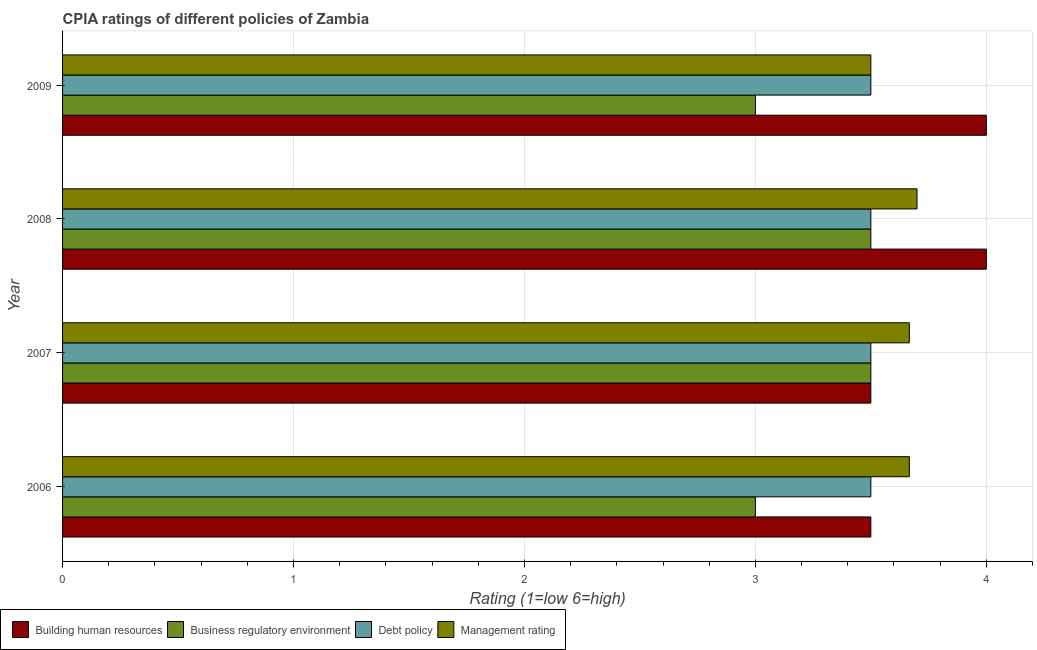How many groups of bars are there?
Your response must be concise. 4. Are the number of bars per tick equal to the number of legend labels?
Give a very brief answer. Yes. In how many cases, is the number of bars for a given year not equal to the number of legend labels?
Offer a very short reply. 0. Across all years, what is the maximum cpia rating of debt policy?
Provide a succinct answer. 3.5. Across all years, what is the minimum cpia rating of debt policy?
Offer a very short reply. 3.5. What is the total cpia rating of management in the graph?
Provide a succinct answer. 14.53. What is the difference between the cpia rating of management in 2006 and that in 2008?
Your answer should be compact. -0.03. In the year 2008, what is the difference between the cpia rating of debt policy and cpia rating of business regulatory environment?
Make the answer very short. 0. What is the ratio of the cpia rating of business regulatory environment in 2006 to that in 2008?
Your answer should be compact. 0.86. Is the cpia rating of debt policy in 2006 less than that in 2007?
Provide a short and direct response. No. What is the difference between the highest and the second highest cpia rating of management?
Provide a succinct answer. 0.03. Is the sum of the cpia rating of building human resources in 2006 and 2009 greater than the maximum cpia rating of management across all years?
Provide a succinct answer. Yes. What does the 1st bar from the top in 2007 represents?
Your answer should be compact. Management rating. What does the 2nd bar from the bottom in 2006 represents?
Your answer should be very brief. Business regulatory environment. Is it the case that in every year, the sum of the cpia rating of building human resources and cpia rating of business regulatory environment is greater than the cpia rating of debt policy?
Provide a succinct answer. Yes. How many bars are there?
Keep it short and to the point. 16. Are all the bars in the graph horizontal?
Provide a succinct answer. Yes. How many years are there in the graph?
Give a very brief answer. 4. What is the difference between two consecutive major ticks on the X-axis?
Make the answer very short. 1. Are the values on the major ticks of X-axis written in scientific E-notation?
Give a very brief answer. No. Does the graph contain any zero values?
Provide a succinct answer. No. Does the graph contain grids?
Your response must be concise. Yes. What is the title of the graph?
Make the answer very short. CPIA ratings of different policies of Zambia. Does "Permission" appear as one of the legend labels in the graph?
Your answer should be compact. No. What is the label or title of the X-axis?
Your response must be concise. Rating (1=low 6=high). What is the label or title of the Y-axis?
Offer a terse response. Year. What is the Rating (1=low 6=high) in Business regulatory environment in 2006?
Your answer should be compact. 3. What is the Rating (1=low 6=high) in Debt policy in 2006?
Keep it short and to the point. 3.5. What is the Rating (1=low 6=high) in Management rating in 2006?
Keep it short and to the point. 3.67. What is the Rating (1=low 6=high) of Building human resources in 2007?
Your answer should be very brief. 3.5. What is the Rating (1=low 6=high) in Business regulatory environment in 2007?
Provide a short and direct response. 3.5. What is the Rating (1=low 6=high) in Debt policy in 2007?
Your answer should be compact. 3.5. What is the Rating (1=low 6=high) in Management rating in 2007?
Keep it short and to the point. 3.67. What is the Rating (1=low 6=high) in Building human resources in 2008?
Your answer should be very brief. 4. What is the Rating (1=low 6=high) of Debt policy in 2008?
Your answer should be compact. 3.5. What is the Rating (1=low 6=high) in Management rating in 2008?
Your answer should be compact. 3.7. What is the Rating (1=low 6=high) in Building human resources in 2009?
Offer a terse response. 4. What is the Rating (1=low 6=high) of Debt policy in 2009?
Your answer should be compact. 3.5. What is the Rating (1=low 6=high) of Management rating in 2009?
Your response must be concise. 3.5. Across all years, what is the maximum Rating (1=low 6=high) in Business regulatory environment?
Make the answer very short. 3.5. Across all years, what is the maximum Rating (1=low 6=high) of Debt policy?
Keep it short and to the point. 3.5. Across all years, what is the minimum Rating (1=low 6=high) of Debt policy?
Give a very brief answer. 3.5. Across all years, what is the minimum Rating (1=low 6=high) of Management rating?
Make the answer very short. 3.5. What is the total Rating (1=low 6=high) of Building human resources in the graph?
Provide a succinct answer. 15. What is the total Rating (1=low 6=high) of Business regulatory environment in the graph?
Offer a very short reply. 13. What is the total Rating (1=low 6=high) of Debt policy in the graph?
Ensure brevity in your answer.  14. What is the total Rating (1=low 6=high) in Management rating in the graph?
Keep it short and to the point. 14.53. What is the difference between the Rating (1=low 6=high) in Building human resources in 2006 and that in 2007?
Make the answer very short. 0. What is the difference between the Rating (1=low 6=high) of Debt policy in 2006 and that in 2007?
Make the answer very short. 0. What is the difference between the Rating (1=low 6=high) of Building human resources in 2006 and that in 2008?
Offer a terse response. -0.5. What is the difference between the Rating (1=low 6=high) of Management rating in 2006 and that in 2008?
Your answer should be very brief. -0.03. What is the difference between the Rating (1=low 6=high) in Business regulatory environment in 2006 and that in 2009?
Offer a very short reply. 0. What is the difference between the Rating (1=low 6=high) of Debt policy in 2006 and that in 2009?
Provide a succinct answer. 0. What is the difference between the Rating (1=low 6=high) in Business regulatory environment in 2007 and that in 2008?
Offer a very short reply. 0. What is the difference between the Rating (1=low 6=high) of Debt policy in 2007 and that in 2008?
Offer a very short reply. 0. What is the difference between the Rating (1=low 6=high) in Management rating in 2007 and that in 2008?
Offer a terse response. -0.03. What is the difference between the Rating (1=low 6=high) in Business regulatory environment in 2007 and that in 2009?
Your answer should be compact. 0.5. What is the difference between the Rating (1=low 6=high) in Debt policy in 2007 and that in 2009?
Give a very brief answer. 0. What is the difference between the Rating (1=low 6=high) of Building human resources in 2008 and that in 2009?
Offer a terse response. 0. What is the difference between the Rating (1=low 6=high) in Building human resources in 2006 and the Rating (1=low 6=high) in Debt policy in 2007?
Your response must be concise. 0. What is the difference between the Rating (1=low 6=high) of Business regulatory environment in 2006 and the Rating (1=low 6=high) of Management rating in 2007?
Your answer should be compact. -0.67. What is the difference between the Rating (1=low 6=high) of Building human resources in 2006 and the Rating (1=low 6=high) of Business regulatory environment in 2008?
Your response must be concise. 0. What is the difference between the Rating (1=low 6=high) in Building human resources in 2006 and the Rating (1=low 6=high) in Debt policy in 2008?
Offer a terse response. 0. What is the difference between the Rating (1=low 6=high) in Building human resources in 2006 and the Rating (1=low 6=high) in Management rating in 2008?
Ensure brevity in your answer.  -0.2. What is the difference between the Rating (1=low 6=high) in Business regulatory environment in 2006 and the Rating (1=low 6=high) in Debt policy in 2008?
Ensure brevity in your answer.  -0.5. What is the difference between the Rating (1=low 6=high) in Business regulatory environment in 2006 and the Rating (1=low 6=high) in Management rating in 2008?
Offer a terse response. -0.7. What is the difference between the Rating (1=low 6=high) in Debt policy in 2006 and the Rating (1=low 6=high) in Management rating in 2008?
Make the answer very short. -0.2. What is the difference between the Rating (1=low 6=high) in Building human resources in 2006 and the Rating (1=low 6=high) in Debt policy in 2009?
Your answer should be very brief. 0. What is the difference between the Rating (1=low 6=high) of Building human resources in 2006 and the Rating (1=low 6=high) of Management rating in 2009?
Provide a short and direct response. 0. What is the difference between the Rating (1=low 6=high) in Debt policy in 2006 and the Rating (1=low 6=high) in Management rating in 2009?
Offer a terse response. 0. What is the difference between the Rating (1=low 6=high) in Building human resources in 2007 and the Rating (1=low 6=high) in Business regulatory environment in 2008?
Your answer should be compact. 0. What is the difference between the Rating (1=low 6=high) in Building human resources in 2007 and the Rating (1=low 6=high) in Debt policy in 2008?
Ensure brevity in your answer.  0. What is the difference between the Rating (1=low 6=high) of Business regulatory environment in 2007 and the Rating (1=low 6=high) of Management rating in 2008?
Offer a terse response. -0.2. What is the difference between the Rating (1=low 6=high) of Building human resources in 2007 and the Rating (1=low 6=high) of Business regulatory environment in 2009?
Keep it short and to the point. 0.5. What is the difference between the Rating (1=low 6=high) of Building human resources in 2007 and the Rating (1=low 6=high) of Management rating in 2009?
Provide a succinct answer. 0. What is the difference between the Rating (1=low 6=high) of Business regulatory environment in 2007 and the Rating (1=low 6=high) of Debt policy in 2009?
Ensure brevity in your answer.  0. What is the difference between the Rating (1=low 6=high) of Debt policy in 2007 and the Rating (1=low 6=high) of Management rating in 2009?
Keep it short and to the point. 0. What is the difference between the Rating (1=low 6=high) in Building human resources in 2008 and the Rating (1=low 6=high) in Debt policy in 2009?
Your response must be concise. 0.5. What is the difference between the Rating (1=low 6=high) in Building human resources in 2008 and the Rating (1=low 6=high) in Management rating in 2009?
Keep it short and to the point. 0.5. What is the difference between the Rating (1=low 6=high) in Business regulatory environment in 2008 and the Rating (1=low 6=high) in Debt policy in 2009?
Offer a terse response. 0. What is the average Rating (1=low 6=high) of Building human resources per year?
Offer a very short reply. 3.75. What is the average Rating (1=low 6=high) in Business regulatory environment per year?
Offer a very short reply. 3.25. What is the average Rating (1=low 6=high) of Debt policy per year?
Make the answer very short. 3.5. What is the average Rating (1=low 6=high) in Management rating per year?
Offer a terse response. 3.63. In the year 2006, what is the difference between the Rating (1=low 6=high) in Building human resources and Rating (1=low 6=high) in Business regulatory environment?
Ensure brevity in your answer.  0.5. In the year 2006, what is the difference between the Rating (1=low 6=high) of Building human resources and Rating (1=low 6=high) of Debt policy?
Ensure brevity in your answer.  0. In the year 2006, what is the difference between the Rating (1=low 6=high) in Building human resources and Rating (1=low 6=high) in Management rating?
Your answer should be very brief. -0.17. In the year 2006, what is the difference between the Rating (1=low 6=high) of Business regulatory environment and Rating (1=low 6=high) of Debt policy?
Your answer should be very brief. -0.5. In the year 2006, what is the difference between the Rating (1=low 6=high) in Business regulatory environment and Rating (1=low 6=high) in Management rating?
Make the answer very short. -0.67. In the year 2006, what is the difference between the Rating (1=low 6=high) in Debt policy and Rating (1=low 6=high) in Management rating?
Keep it short and to the point. -0.17. In the year 2007, what is the difference between the Rating (1=low 6=high) in Building human resources and Rating (1=low 6=high) in Debt policy?
Offer a terse response. 0. In the year 2007, what is the difference between the Rating (1=low 6=high) in Business regulatory environment and Rating (1=low 6=high) in Debt policy?
Your answer should be compact. 0. In the year 2007, what is the difference between the Rating (1=low 6=high) in Debt policy and Rating (1=low 6=high) in Management rating?
Keep it short and to the point. -0.17. In the year 2008, what is the difference between the Rating (1=low 6=high) in Building human resources and Rating (1=low 6=high) in Debt policy?
Your answer should be compact. 0.5. In the year 2008, what is the difference between the Rating (1=low 6=high) in Building human resources and Rating (1=low 6=high) in Management rating?
Make the answer very short. 0.3. In the year 2008, what is the difference between the Rating (1=low 6=high) in Business regulatory environment and Rating (1=low 6=high) in Debt policy?
Make the answer very short. 0. In the year 2008, what is the difference between the Rating (1=low 6=high) of Business regulatory environment and Rating (1=low 6=high) of Management rating?
Your response must be concise. -0.2. In the year 2008, what is the difference between the Rating (1=low 6=high) of Debt policy and Rating (1=low 6=high) of Management rating?
Keep it short and to the point. -0.2. In the year 2009, what is the difference between the Rating (1=low 6=high) in Building human resources and Rating (1=low 6=high) in Business regulatory environment?
Ensure brevity in your answer.  1. In the year 2009, what is the difference between the Rating (1=low 6=high) of Building human resources and Rating (1=low 6=high) of Debt policy?
Provide a succinct answer. 0.5. In the year 2009, what is the difference between the Rating (1=low 6=high) in Business regulatory environment and Rating (1=low 6=high) in Debt policy?
Offer a terse response. -0.5. What is the ratio of the Rating (1=low 6=high) in Business regulatory environment in 2006 to that in 2007?
Your response must be concise. 0.86. What is the ratio of the Rating (1=low 6=high) in Management rating in 2006 to that in 2007?
Provide a succinct answer. 1. What is the ratio of the Rating (1=low 6=high) of Building human resources in 2006 to that in 2008?
Your answer should be very brief. 0.88. What is the ratio of the Rating (1=low 6=high) of Debt policy in 2006 to that in 2008?
Provide a succinct answer. 1. What is the ratio of the Rating (1=low 6=high) in Building human resources in 2006 to that in 2009?
Offer a terse response. 0.88. What is the ratio of the Rating (1=low 6=high) in Management rating in 2006 to that in 2009?
Keep it short and to the point. 1.05. What is the ratio of the Rating (1=low 6=high) of Building human resources in 2007 to that in 2008?
Your answer should be compact. 0.88. What is the ratio of the Rating (1=low 6=high) of Debt policy in 2007 to that in 2008?
Offer a terse response. 1. What is the ratio of the Rating (1=low 6=high) of Management rating in 2007 to that in 2008?
Provide a succinct answer. 0.99. What is the ratio of the Rating (1=low 6=high) in Business regulatory environment in 2007 to that in 2009?
Your answer should be very brief. 1.17. What is the ratio of the Rating (1=low 6=high) in Debt policy in 2007 to that in 2009?
Provide a short and direct response. 1. What is the ratio of the Rating (1=low 6=high) in Management rating in 2007 to that in 2009?
Your answer should be very brief. 1.05. What is the ratio of the Rating (1=low 6=high) in Debt policy in 2008 to that in 2009?
Ensure brevity in your answer.  1. What is the ratio of the Rating (1=low 6=high) of Management rating in 2008 to that in 2009?
Keep it short and to the point. 1.06. What is the difference between the highest and the second highest Rating (1=low 6=high) in Business regulatory environment?
Make the answer very short. 0. What is the difference between the highest and the second highest Rating (1=low 6=high) of Debt policy?
Ensure brevity in your answer.  0. What is the difference between the highest and the second highest Rating (1=low 6=high) in Management rating?
Make the answer very short. 0.03. What is the difference between the highest and the lowest Rating (1=low 6=high) in Business regulatory environment?
Offer a very short reply. 0.5. What is the difference between the highest and the lowest Rating (1=low 6=high) in Debt policy?
Provide a short and direct response. 0. What is the difference between the highest and the lowest Rating (1=low 6=high) in Management rating?
Ensure brevity in your answer.  0.2. 